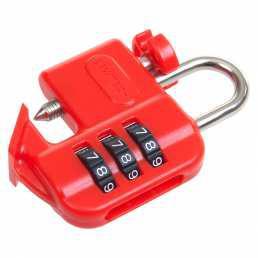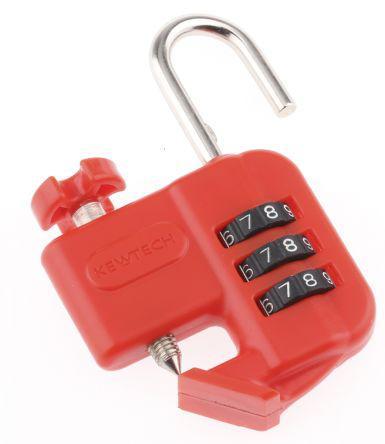The first image is the image on the left, the second image is the image on the right. For the images displayed, is the sentence "There are two warning tags with a red lock." factually correct? Answer yes or no. No. 